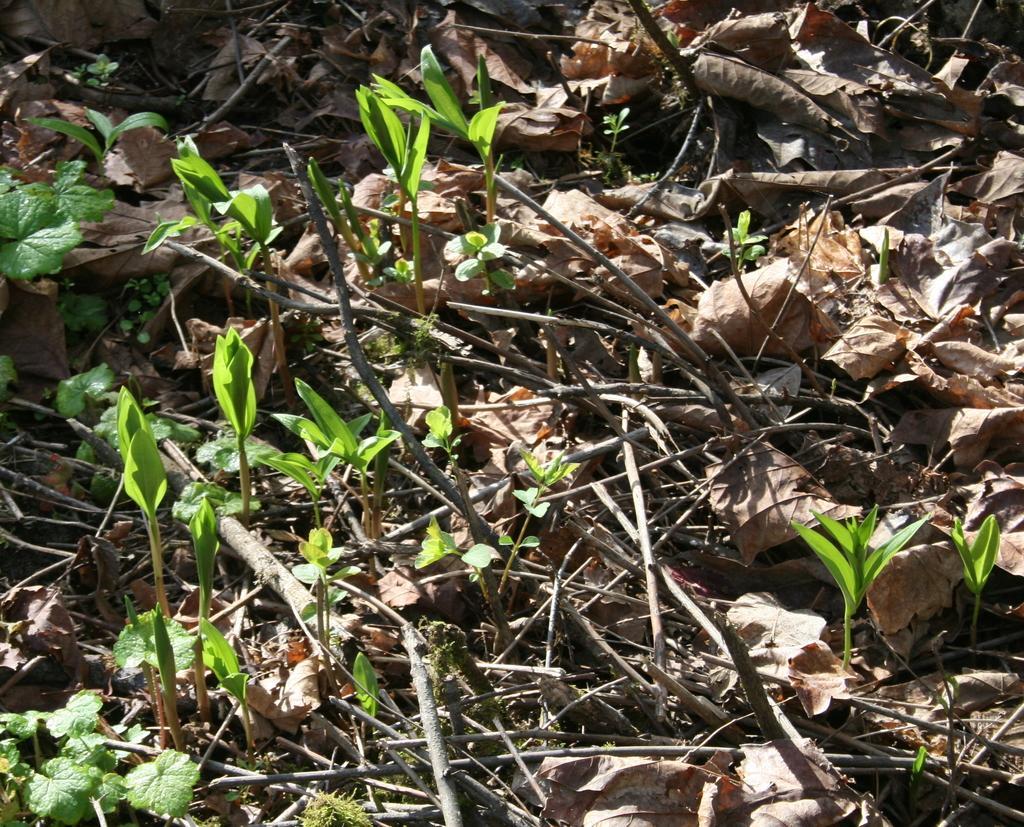Could you give a brief overview of what you see in this image? In this picture I can see there are few plants, twigs, dry leaves and small plants on the ground and there is soil. 